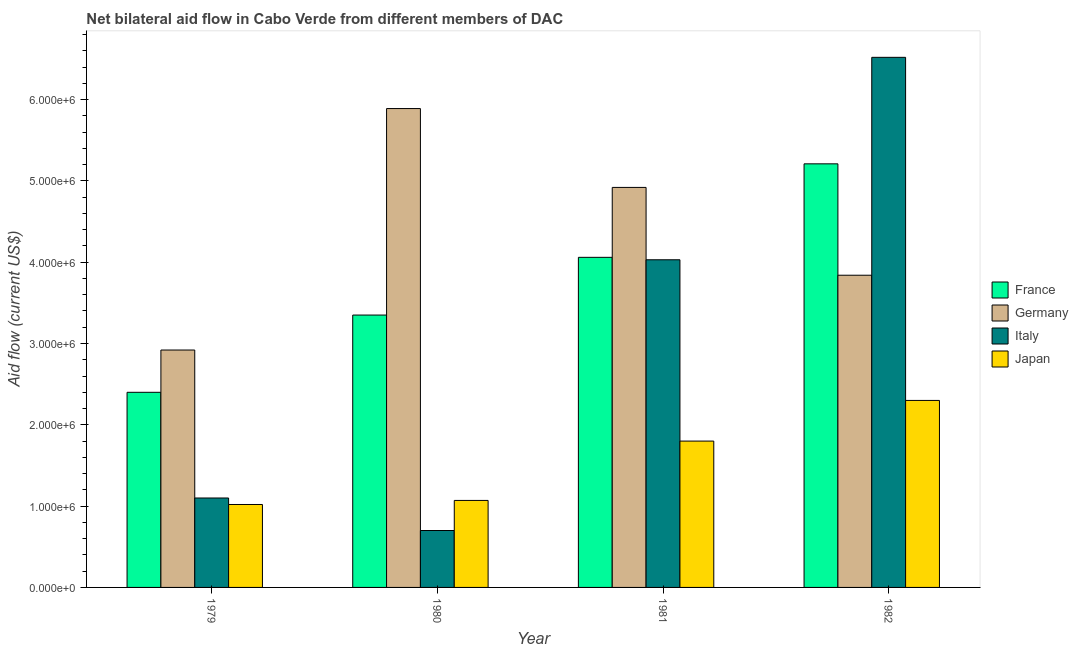How many groups of bars are there?
Your response must be concise. 4. How many bars are there on the 4th tick from the left?
Offer a very short reply. 4. How many bars are there on the 4th tick from the right?
Ensure brevity in your answer.  4. What is the label of the 4th group of bars from the left?
Offer a terse response. 1982. In how many cases, is the number of bars for a given year not equal to the number of legend labels?
Give a very brief answer. 0. What is the amount of aid given by italy in 1982?
Your answer should be compact. 6.52e+06. Across all years, what is the maximum amount of aid given by germany?
Your answer should be very brief. 5.89e+06. Across all years, what is the minimum amount of aid given by france?
Give a very brief answer. 2.40e+06. In which year was the amount of aid given by germany minimum?
Your answer should be compact. 1979. What is the total amount of aid given by france in the graph?
Make the answer very short. 1.50e+07. What is the difference between the amount of aid given by france in 1979 and that in 1981?
Provide a short and direct response. -1.66e+06. What is the difference between the amount of aid given by germany in 1979 and the amount of aid given by france in 1980?
Keep it short and to the point. -2.97e+06. What is the average amount of aid given by japan per year?
Your answer should be compact. 1.55e+06. What is the ratio of the amount of aid given by japan in 1979 to that in 1982?
Offer a terse response. 0.44. Is the difference between the amount of aid given by germany in 1979 and 1982 greater than the difference between the amount of aid given by japan in 1979 and 1982?
Keep it short and to the point. No. What is the difference between the highest and the second highest amount of aid given by italy?
Keep it short and to the point. 2.49e+06. What is the difference between the highest and the lowest amount of aid given by italy?
Ensure brevity in your answer.  5.82e+06. In how many years, is the amount of aid given by germany greater than the average amount of aid given by germany taken over all years?
Provide a succinct answer. 2. What does the 1st bar from the left in 1979 represents?
Keep it short and to the point. France. What does the 2nd bar from the right in 1981 represents?
Your answer should be very brief. Italy. Is it the case that in every year, the sum of the amount of aid given by france and amount of aid given by germany is greater than the amount of aid given by italy?
Your response must be concise. Yes. How many bars are there?
Provide a succinct answer. 16. What is the difference between two consecutive major ticks on the Y-axis?
Offer a terse response. 1.00e+06. Does the graph contain grids?
Your answer should be very brief. No. How many legend labels are there?
Ensure brevity in your answer.  4. What is the title of the graph?
Offer a terse response. Net bilateral aid flow in Cabo Verde from different members of DAC. What is the Aid flow (current US$) in France in 1979?
Offer a very short reply. 2.40e+06. What is the Aid flow (current US$) in Germany in 1979?
Keep it short and to the point. 2.92e+06. What is the Aid flow (current US$) of Italy in 1979?
Provide a succinct answer. 1.10e+06. What is the Aid flow (current US$) of Japan in 1979?
Your answer should be compact. 1.02e+06. What is the Aid flow (current US$) of France in 1980?
Your answer should be compact. 3.35e+06. What is the Aid flow (current US$) in Germany in 1980?
Make the answer very short. 5.89e+06. What is the Aid flow (current US$) in Japan in 1980?
Give a very brief answer. 1.07e+06. What is the Aid flow (current US$) of France in 1981?
Give a very brief answer. 4.06e+06. What is the Aid flow (current US$) in Germany in 1981?
Your response must be concise. 4.92e+06. What is the Aid flow (current US$) of Italy in 1981?
Your answer should be very brief. 4.03e+06. What is the Aid flow (current US$) of Japan in 1981?
Offer a terse response. 1.80e+06. What is the Aid flow (current US$) of France in 1982?
Give a very brief answer. 5.21e+06. What is the Aid flow (current US$) in Germany in 1982?
Ensure brevity in your answer.  3.84e+06. What is the Aid flow (current US$) in Italy in 1982?
Ensure brevity in your answer.  6.52e+06. What is the Aid flow (current US$) in Japan in 1982?
Your response must be concise. 2.30e+06. Across all years, what is the maximum Aid flow (current US$) in France?
Provide a short and direct response. 5.21e+06. Across all years, what is the maximum Aid flow (current US$) of Germany?
Ensure brevity in your answer.  5.89e+06. Across all years, what is the maximum Aid flow (current US$) in Italy?
Provide a short and direct response. 6.52e+06. Across all years, what is the maximum Aid flow (current US$) of Japan?
Your answer should be compact. 2.30e+06. Across all years, what is the minimum Aid flow (current US$) in France?
Your response must be concise. 2.40e+06. Across all years, what is the minimum Aid flow (current US$) in Germany?
Make the answer very short. 2.92e+06. Across all years, what is the minimum Aid flow (current US$) of Italy?
Your answer should be very brief. 7.00e+05. Across all years, what is the minimum Aid flow (current US$) in Japan?
Make the answer very short. 1.02e+06. What is the total Aid flow (current US$) in France in the graph?
Your answer should be very brief. 1.50e+07. What is the total Aid flow (current US$) of Germany in the graph?
Ensure brevity in your answer.  1.76e+07. What is the total Aid flow (current US$) in Italy in the graph?
Provide a succinct answer. 1.24e+07. What is the total Aid flow (current US$) in Japan in the graph?
Ensure brevity in your answer.  6.19e+06. What is the difference between the Aid flow (current US$) of France in 1979 and that in 1980?
Provide a short and direct response. -9.50e+05. What is the difference between the Aid flow (current US$) of Germany in 1979 and that in 1980?
Keep it short and to the point. -2.97e+06. What is the difference between the Aid flow (current US$) in Italy in 1979 and that in 1980?
Ensure brevity in your answer.  4.00e+05. What is the difference between the Aid flow (current US$) in France in 1979 and that in 1981?
Keep it short and to the point. -1.66e+06. What is the difference between the Aid flow (current US$) in Germany in 1979 and that in 1981?
Ensure brevity in your answer.  -2.00e+06. What is the difference between the Aid flow (current US$) in Italy in 1979 and that in 1981?
Ensure brevity in your answer.  -2.93e+06. What is the difference between the Aid flow (current US$) in Japan in 1979 and that in 1981?
Keep it short and to the point. -7.80e+05. What is the difference between the Aid flow (current US$) in France in 1979 and that in 1982?
Provide a short and direct response. -2.81e+06. What is the difference between the Aid flow (current US$) in Germany in 1979 and that in 1982?
Give a very brief answer. -9.20e+05. What is the difference between the Aid flow (current US$) in Italy in 1979 and that in 1982?
Give a very brief answer. -5.42e+06. What is the difference between the Aid flow (current US$) of Japan in 1979 and that in 1982?
Your answer should be very brief. -1.28e+06. What is the difference between the Aid flow (current US$) of France in 1980 and that in 1981?
Give a very brief answer. -7.10e+05. What is the difference between the Aid flow (current US$) of Germany in 1980 and that in 1981?
Keep it short and to the point. 9.70e+05. What is the difference between the Aid flow (current US$) of Italy in 1980 and that in 1981?
Make the answer very short. -3.33e+06. What is the difference between the Aid flow (current US$) in Japan in 1980 and that in 1981?
Offer a very short reply. -7.30e+05. What is the difference between the Aid flow (current US$) of France in 1980 and that in 1982?
Offer a very short reply. -1.86e+06. What is the difference between the Aid flow (current US$) in Germany in 1980 and that in 1982?
Ensure brevity in your answer.  2.05e+06. What is the difference between the Aid flow (current US$) in Italy in 1980 and that in 1982?
Your answer should be very brief. -5.82e+06. What is the difference between the Aid flow (current US$) in Japan in 1980 and that in 1982?
Provide a short and direct response. -1.23e+06. What is the difference between the Aid flow (current US$) of France in 1981 and that in 1982?
Provide a succinct answer. -1.15e+06. What is the difference between the Aid flow (current US$) of Germany in 1981 and that in 1982?
Your answer should be very brief. 1.08e+06. What is the difference between the Aid flow (current US$) of Italy in 1981 and that in 1982?
Ensure brevity in your answer.  -2.49e+06. What is the difference between the Aid flow (current US$) in Japan in 1981 and that in 1982?
Make the answer very short. -5.00e+05. What is the difference between the Aid flow (current US$) of France in 1979 and the Aid flow (current US$) of Germany in 1980?
Offer a terse response. -3.49e+06. What is the difference between the Aid flow (current US$) in France in 1979 and the Aid flow (current US$) in Italy in 1980?
Your response must be concise. 1.70e+06. What is the difference between the Aid flow (current US$) in France in 1979 and the Aid flow (current US$) in Japan in 1980?
Ensure brevity in your answer.  1.33e+06. What is the difference between the Aid flow (current US$) of Germany in 1979 and the Aid flow (current US$) of Italy in 1980?
Your answer should be compact. 2.22e+06. What is the difference between the Aid flow (current US$) of Germany in 1979 and the Aid flow (current US$) of Japan in 1980?
Give a very brief answer. 1.85e+06. What is the difference between the Aid flow (current US$) of Italy in 1979 and the Aid flow (current US$) of Japan in 1980?
Your answer should be compact. 3.00e+04. What is the difference between the Aid flow (current US$) in France in 1979 and the Aid flow (current US$) in Germany in 1981?
Offer a very short reply. -2.52e+06. What is the difference between the Aid flow (current US$) in France in 1979 and the Aid flow (current US$) in Italy in 1981?
Provide a short and direct response. -1.63e+06. What is the difference between the Aid flow (current US$) in France in 1979 and the Aid flow (current US$) in Japan in 1981?
Your answer should be compact. 6.00e+05. What is the difference between the Aid flow (current US$) of Germany in 1979 and the Aid flow (current US$) of Italy in 1981?
Offer a terse response. -1.11e+06. What is the difference between the Aid flow (current US$) of Germany in 1979 and the Aid flow (current US$) of Japan in 1981?
Provide a short and direct response. 1.12e+06. What is the difference between the Aid flow (current US$) in Italy in 1979 and the Aid flow (current US$) in Japan in 1981?
Ensure brevity in your answer.  -7.00e+05. What is the difference between the Aid flow (current US$) of France in 1979 and the Aid flow (current US$) of Germany in 1982?
Provide a succinct answer. -1.44e+06. What is the difference between the Aid flow (current US$) of France in 1979 and the Aid flow (current US$) of Italy in 1982?
Offer a very short reply. -4.12e+06. What is the difference between the Aid flow (current US$) in Germany in 1979 and the Aid flow (current US$) in Italy in 1982?
Your response must be concise. -3.60e+06. What is the difference between the Aid flow (current US$) in Germany in 1979 and the Aid flow (current US$) in Japan in 1982?
Offer a terse response. 6.20e+05. What is the difference between the Aid flow (current US$) of Italy in 1979 and the Aid flow (current US$) of Japan in 1982?
Ensure brevity in your answer.  -1.20e+06. What is the difference between the Aid flow (current US$) of France in 1980 and the Aid flow (current US$) of Germany in 1981?
Provide a succinct answer. -1.57e+06. What is the difference between the Aid flow (current US$) in France in 1980 and the Aid flow (current US$) in Italy in 1981?
Provide a short and direct response. -6.80e+05. What is the difference between the Aid flow (current US$) of France in 1980 and the Aid flow (current US$) of Japan in 1981?
Make the answer very short. 1.55e+06. What is the difference between the Aid flow (current US$) in Germany in 1980 and the Aid flow (current US$) in Italy in 1981?
Keep it short and to the point. 1.86e+06. What is the difference between the Aid flow (current US$) of Germany in 1980 and the Aid flow (current US$) of Japan in 1981?
Make the answer very short. 4.09e+06. What is the difference between the Aid flow (current US$) in Italy in 1980 and the Aid flow (current US$) in Japan in 1981?
Offer a terse response. -1.10e+06. What is the difference between the Aid flow (current US$) of France in 1980 and the Aid flow (current US$) of Germany in 1982?
Offer a terse response. -4.90e+05. What is the difference between the Aid flow (current US$) in France in 1980 and the Aid flow (current US$) in Italy in 1982?
Offer a terse response. -3.17e+06. What is the difference between the Aid flow (current US$) in France in 1980 and the Aid flow (current US$) in Japan in 1982?
Provide a succinct answer. 1.05e+06. What is the difference between the Aid flow (current US$) of Germany in 1980 and the Aid flow (current US$) of Italy in 1982?
Your answer should be compact. -6.30e+05. What is the difference between the Aid flow (current US$) of Germany in 1980 and the Aid flow (current US$) of Japan in 1982?
Make the answer very short. 3.59e+06. What is the difference between the Aid flow (current US$) of Italy in 1980 and the Aid flow (current US$) of Japan in 1982?
Offer a very short reply. -1.60e+06. What is the difference between the Aid flow (current US$) of France in 1981 and the Aid flow (current US$) of Germany in 1982?
Your answer should be very brief. 2.20e+05. What is the difference between the Aid flow (current US$) of France in 1981 and the Aid flow (current US$) of Italy in 1982?
Provide a short and direct response. -2.46e+06. What is the difference between the Aid flow (current US$) of France in 1981 and the Aid flow (current US$) of Japan in 1982?
Offer a terse response. 1.76e+06. What is the difference between the Aid flow (current US$) in Germany in 1981 and the Aid flow (current US$) in Italy in 1982?
Give a very brief answer. -1.60e+06. What is the difference between the Aid flow (current US$) of Germany in 1981 and the Aid flow (current US$) of Japan in 1982?
Make the answer very short. 2.62e+06. What is the difference between the Aid flow (current US$) in Italy in 1981 and the Aid flow (current US$) in Japan in 1982?
Ensure brevity in your answer.  1.73e+06. What is the average Aid flow (current US$) of France per year?
Offer a terse response. 3.76e+06. What is the average Aid flow (current US$) of Germany per year?
Keep it short and to the point. 4.39e+06. What is the average Aid flow (current US$) in Italy per year?
Give a very brief answer. 3.09e+06. What is the average Aid flow (current US$) in Japan per year?
Give a very brief answer. 1.55e+06. In the year 1979, what is the difference between the Aid flow (current US$) of France and Aid flow (current US$) of Germany?
Ensure brevity in your answer.  -5.20e+05. In the year 1979, what is the difference between the Aid flow (current US$) in France and Aid flow (current US$) in Italy?
Your answer should be compact. 1.30e+06. In the year 1979, what is the difference between the Aid flow (current US$) in France and Aid flow (current US$) in Japan?
Keep it short and to the point. 1.38e+06. In the year 1979, what is the difference between the Aid flow (current US$) in Germany and Aid flow (current US$) in Italy?
Provide a succinct answer. 1.82e+06. In the year 1979, what is the difference between the Aid flow (current US$) of Germany and Aid flow (current US$) of Japan?
Your answer should be compact. 1.90e+06. In the year 1980, what is the difference between the Aid flow (current US$) in France and Aid flow (current US$) in Germany?
Provide a short and direct response. -2.54e+06. In the year 1980, what is the difference between the Aid flow (current US$) of France and Aid flow (current US$) of Italy?
Make the answer very short. 2.65e+06. In the year 1980, what is the difference between the Aid flow (current US$) in France and Aid flow (current US$) in Japan?
Your answer should be compact. 2.28e+06. In the year 1980, what is the difference between the Aid flow (current US$) in Germany and Aid flow (current US$) in Italy?
Keep it short and to the point. 5.19e+06. In the year 1980, what is the difference between the Aid flow (current US$) in Germany and Aid flow (current US$) in Japan?
Your answer should be compact. 4.82e+06. In the year 1980, what is the difference between the Aid flow (current US$) of Italy and Aid flow (current US$) of Japan?
Ensure brevity in your answer.  -3.70e+05. In the year 1981, what is the difference between the Aid flow (current US$) of France and Aid flow (current US$) of Germany?
Offer a very short reply. -8.60e+05. In the year 1981, what is the difference between the Aid flow (current US$) of France and Aid flow (current US$) of Italy?
Ensure brevity in your answer.  3.00e+04. In the year 1981, what is the difference between the Aid flow (current US$) in France and Aid flow (current US$) in Japan?
Ensure brevity in your answer.  2.26e+06. In the year 1981, what is the difference between the Aid flow (current US$) in Germany and Aid flow (current US$) in Italy?
Give a very brief answer. 8.90e+05. In the year 1981, what is the difference between the Aid flow (current US$) in Germany and Aid flow (current US$) in Japan?
Provide a succinct answer. 3.12e+06. In the year 1981, what is the difference between the Aid flow (current US$) in Italy and Aid flow (current US$) in Japan?
Provide a short and direct response. 2.23e+06. In the year 1982, what is the difference between the Aid flow (current US$) of France and Aid flow (current US$) of Germany?
Provide a succinct answer. 1.37e+06. In the year 1982, what is the difference between the Aid flow (current US$) in France and Aid flow (current US$) in Italy?
Provide a succinct answer. -1.31e+06. In the year 1982, what is the difference between the Aid flow (current US$) in France and Aid flow (current US$) in Japan?
Keep it short and to the point. 2.91e+06. In the year 1982, what is the difference between the Aid flow (current US$) in Germany and Aid flow (current US$) in Italy?
Provide a short and direct response. -2.68e+06. In the year 1982, what is the difference between the Aid flow (current US$) in Germany and Aid flow (current US$) in Japan?
Make the answer very short. 1.54e+06. In the year 1982, what is the difference between the Aid flow (current US$) of Italy and Aid flow (current US$) of Japan?
Your answer should be compact. 4.22e+06. What is the ratio of the Aid flow (current US$) of France in 1979 to that in 1980?
Your response must be concise. 0.72. What is the ratio of the Aid flow (current US$) of Germany in 1979 to that in 1980?
Your answer should be compact. 0.5. What is the ratio of the Aid flow (current US$) of Italy in 1979 to that in 1980?
Ensure brevity in your answer.  1.57. What is the ratio of the Aid flow (current US$) in Japan in 1979 to that in 1980?
Offer a very short reply. 0.95. What is the ratio of the Aid flow (current US$) in France in 1979 to that in 1981?
Your answer should be compact. 0.59. What is the ratio of the Aid flow (current US$) of Germany in 1979 to that in 1981?
Provide a succinct answer. 0.59. What is the ratio of the Aid flow (current US$) of Italy in 1979 to that in 1981?
Keep it short and to the point. 0.27. What is the ratio of the Aid flow (current US$) of Japan in 1979 to that in 1981?
Provide a succinct answer. 0.57. What is the ratio of the Aid flow (current US$) in France in 1979 to that in 1982?
Offer a very short reply. 0.46. What is the ratio of the Aid flow (current US$) in Germany in 1979 to that in 1982?
Ensure brevity in your answer.  0.76. What is the ratio of the Aid flow (current US$) in Italy in 1979 to that in 1982?
Your answer should be compact. 0.17. What is the ratio of the Aid flow (current US$) of Japan in 1979 to that in 1982?
Your response must be concise. 0.44. What is the ratio of the Aid flow (current US$) of France in 1980 to that in 1981?
Make the answer very short. 0.83. What is the ratio of the Aid flow (current US$) in Germany in 1980 to that in 1981?
Keep it short and to the point. 1.2. What is the ratio of the Aid flow (current US$) in Italy in 1980 to that in 1981?
Ensure brevity in your answer.  0.17. What is the ratio of the Aid flow (current US$) of Japan in 1980 to that in 1981?
Make the answer very short. 0.59. What is the ratio of the Aid flow (current US$) in France in 1980 to that in 1982?
Provide a succinct answer. 0.64. What is the ratio of the Aid flow (current US$) in Germany in 1980 to that in 1982?
Make the answer very short. 1.53. What is the ratio of the Aid flow (current US$) in Italy in 1980 to that in 1982?
Ensure brevity in your answer.  0.11. What is the ratio of the Aid flow (current US$) in Japan in 1980 to that in 1982?
Your answer should be very brief. 0.47. What is the ratio of the Aid flow (current US$) of France in 1981 to that in 1982?
Provide a short and direct response. 0.78. What is the ratio of the Aid flow (current US$) in Germany in 1981 to that in 1982?
Provide a short and direct response. 1.28. What is the ratio of the Aid flow (current US$) in Italy in 1981 to that in 1982?
Your answer should be very brief. 0.62. What is the ratio of the Aid flow (current US$) in Japan in 1981 to that in 1982?
Offer a terse response. 0.78. What is the difference between the highest and the second highest Aid flow (current US$) in France?
Offer a very short reply. 1.15e+06. What is the difference between the highest and the second highest Aid flow (current US$) in Germany?
Give a very brief answer. 9.70e+05. What is the difference between the highest and the second highest Aid flow (current US$) in Italy?
Give a very brief answer. 2.49e+06. What is the difference between the highest and the lowest Aid flow (current US$) in France?
Keep it short and to the point. 2.81e+06. What is the difference between the highest and the lowest Aid flow (current US$) in Germany?
Ensure brevity in your answer.  2.97e+06. What is the difference between the highest and the lowest Aid flow (current US$) of Italy?
Keep it short and to the point. 5.82e+06. What is the difference between the highest and the lowest Aid flow (current US$) of Japan?
Your answer should be very brief. 1.28e+06. 